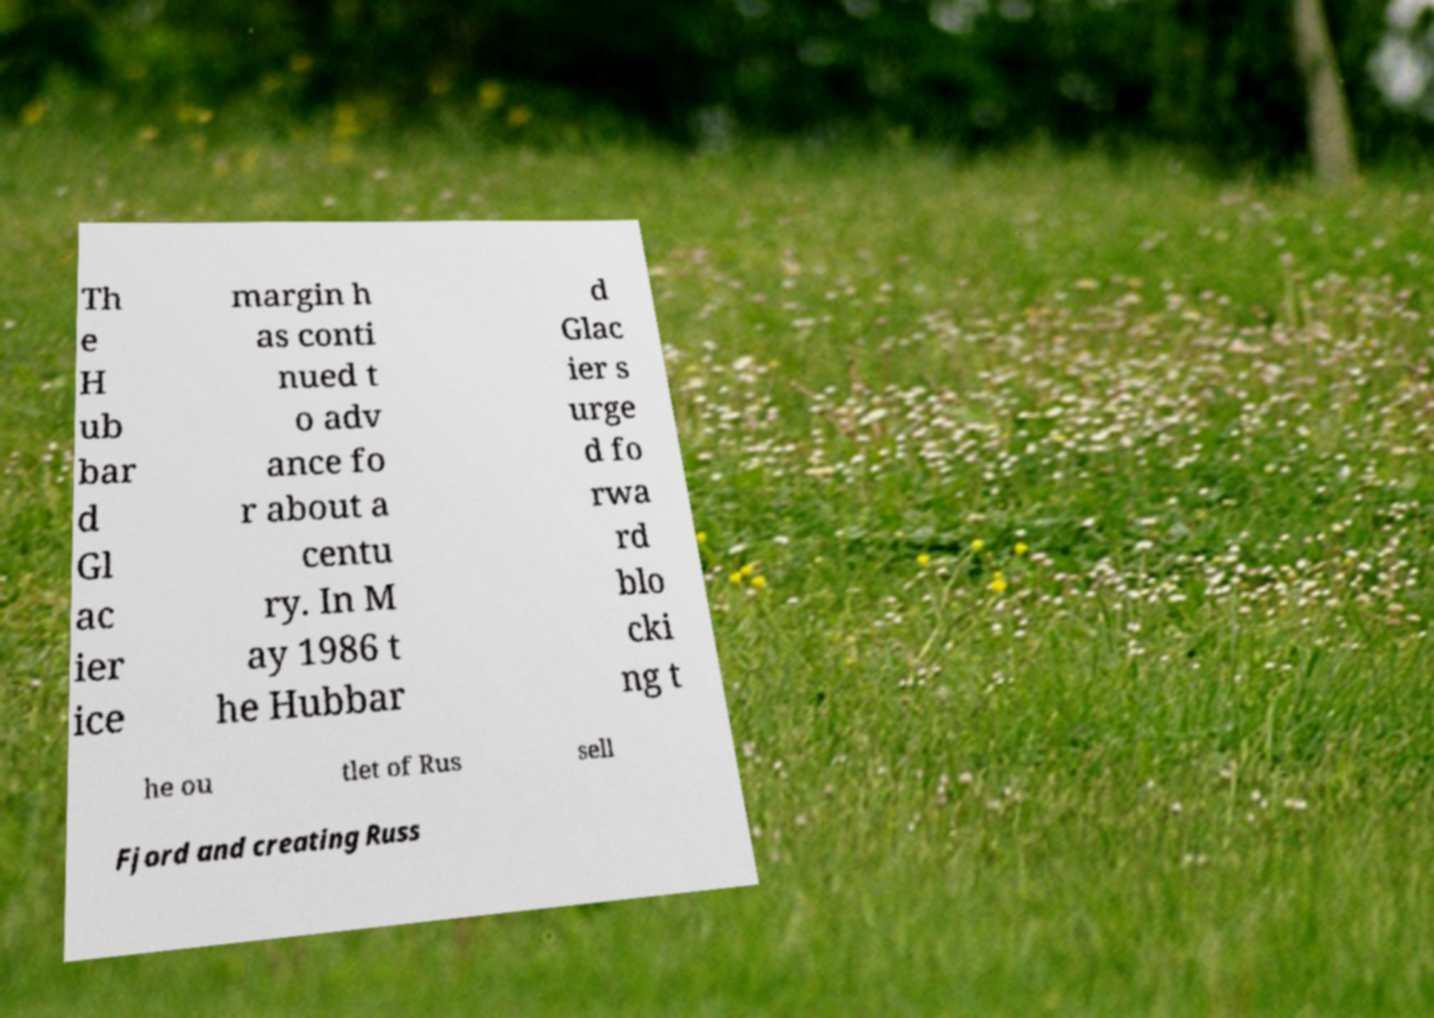Please read and relay the text visible in this image. What does it say? Th e H ub bar d Gl ac ier ice margin h as conti nued t o adv ance fo r about a centu ry. In M ay 1986 t he Hubbar d Glac ier s urge d fo rwa rd blo cki ng t he ou tlet of Rus sell Fjord and creating Russ 